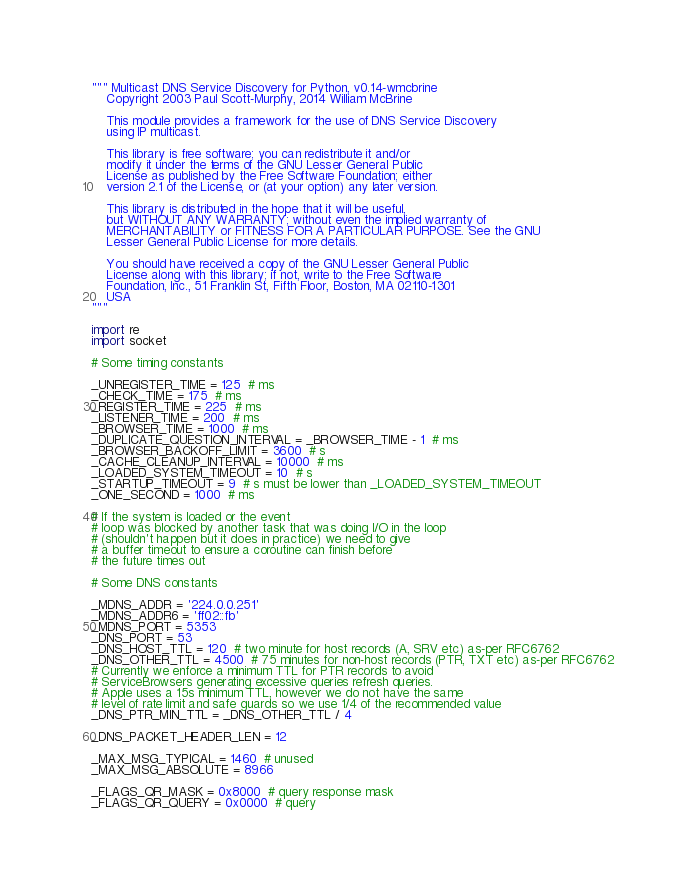<code> <loc_0><loc_0><loc_500><loc_500><_Python_>""" Multicast DNS Service Discovery for Python, v0.14-wmcbrine
    Copyright 2003 Paul Scott-Murphy, 2014 William McBrine

    This module provides a framework for the use of DNS Service Discovery
    using IP multicast.

    This library is free software; you can redistribute it and/or
    modify it under the terms of the GNU Lesser General Public
    License as published by the Free Software Foundation; either
    version 2.1 of the License, or (at your option) any later version.

    This library is distributed in the hope that it will be useful,
    but WITHOUT ANY WARRANTY; without even the implied warranty of
    MERCHANTABILITY or FITNESS FOR A PARTICULAR PURPOSE. See the GNU
    Lesser General Public License for more details.

    You should have received a copy of the GNU Lesser General Public
    License along with this library; if not, write to the Free Software
    Foundation, Inc., 51 Franklin St, Fifth Floor, Boston, MA 02110-1301
    USA
"""

import re
import socket

# Some timing constants

_UNREGISTER_TIME = 125  # ms
_CHECK_TIME = 175  # ms
_REGISTER_TIME = 225  # ms
_LISTENER_TIME = 200  # ms
_BROWSER_TIME = 1000  # ms
_DUPLICATE_QUESTION_INTERVAL = _BROWSER_TIME - 1  # ms
_BROWSER_BACKOFF_LIMIT = 3600  # s
_CACHE_CLEANUP_INTERVAL = 10000  # ms
_LOADED_SYSTEM_TIMEOUT = 10  # s
_STARTUP_TIMEOUT = 9  # s must be lower than _LOADED_SYSTEM_TIMEOUT
_ONE_SECOND = 1000  # ms

# If the system is loaded or the event
# loop was blocked by another task that was doing I/O in the loop
# (shouldn't happen but it does in practice) we need to give
# a buffer timeout to ensure a coroutine can finish before
# the future times out

# Some DNS constants

_MDNS_ADDR = '224.0.0.251'
_MDNS_ADDR6 = 'ff02::fb'
_MDNS_PORT = 5353
_DNS_PORT = 53
_DNS_HOST_TTL = 120  # two minute for host records (A, SRV etc) as-per RFC6762
_DNS_OTHER_TTL = 4500  # 75 minutes for non-host records (PTR, TXT etc) as-per RFC6762
# Currently we enforce a minimum TTL for PTR records to avoid
# ServiceBrowsers generating excessive queries refresh queries.
# Apple uses a 15s minimum TTL, however we do not have the same
# level of rate limit and safe guards so we use 1/4 of the recommended value
_DNS_PTR_MIN_TTL = _DNS_OTHER_TTL / 4

_DNS_PACKET_HEADER_LEN = 12

_MAX_MSG_TYPICAL = 1460  # unused
_MAX_MSG_ABSOLUTE = 8966

_FLAGS_QR_MASK = 0x8000  # query response mask
_FLAGS_QR_QUERY = 0x0000  # query</code> 